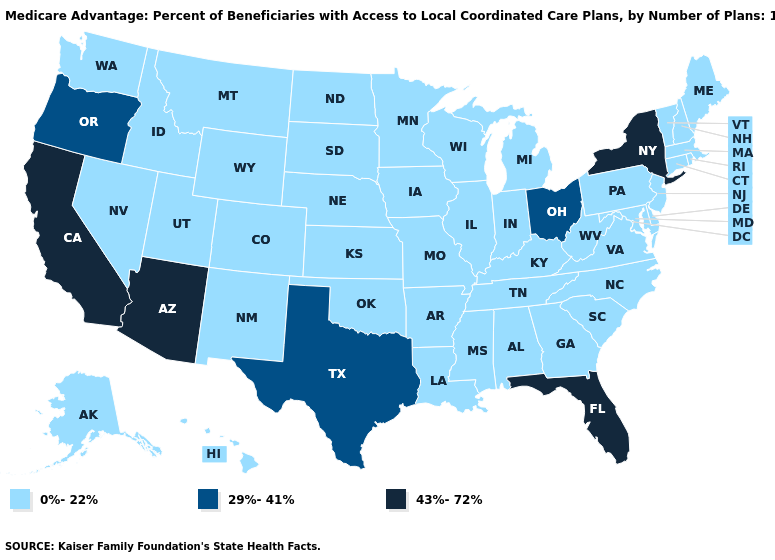What is the value of West Virginia?
Short answer required. 0%-22%. What is the value of Idaho?
Give a very brief answer. 0%-22%. Among the states that border Alabama , which have the lowest value?
Quick response, please. Georgia, Mississippi, Tennessee. Name the states that have a value in the range 29%-41%?
Be succinct. Ohio, Oregon, Texas. What is the value of Alabama?
Write a very short answer. 0%-22%. What is the value of Kentucky?
Short answer required. 0%-22%. Name the states that have a value in the range 29%-41%?
Give a very brief answer. Ohio, Oregon, Texas. Which states have the lowest value in the MidWest?
Be succinct. Iowa, Illinois, Indiana, Kansas, Michigan, Minnesota, Missouri, North Dakota, Nebraska, South Dakota, Wisconsin. What is the value of Nevada?
Concise answer only. 0%-22%. What is the value of South Dakota?
Give a very brief answer. 0%-22%. What is the value of Vermont?
Keep it brief. 0%-22%. Does New York have the highest value in the Northeast?
Be succinct. Yes. Name the states that have a value in the range 0%-22%?
Give a very brief answer. Alaska, Alabama, Arkansas, Colorado, Connecticut, Delaware, Georgia, Hawaii, Iowa, Idaho, Illinois, Indiana, Kansas, Kentucky, Louisiana, Massachusetts, Maryland, Maine, Michigan, Minnesota, Missouri, Mississippi, Montana, North Carolina, North Dakota, Nebraska, New Hampshire, New Jersey, New Mexico, Nevada, Oklahoma, Pennsylvania, Rhode Island, South Carolina, South Dakota, Tennessee, Utah, Virginia, Vermont, Washington, Wisconsin, West Virginia, Wyoming. Which states have the highest value in the USA?
Write a very short answer. Arizona, California, Florida, New York. 